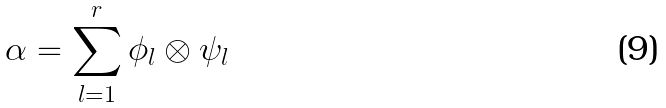Convert formula to latex. <formula><loc_0><loc_0><loc_500><loc_500>\alpha = \sum _ { l = 1 } ^ { r } \phi _ { l } \otimes \psi _ { l }</formula> 